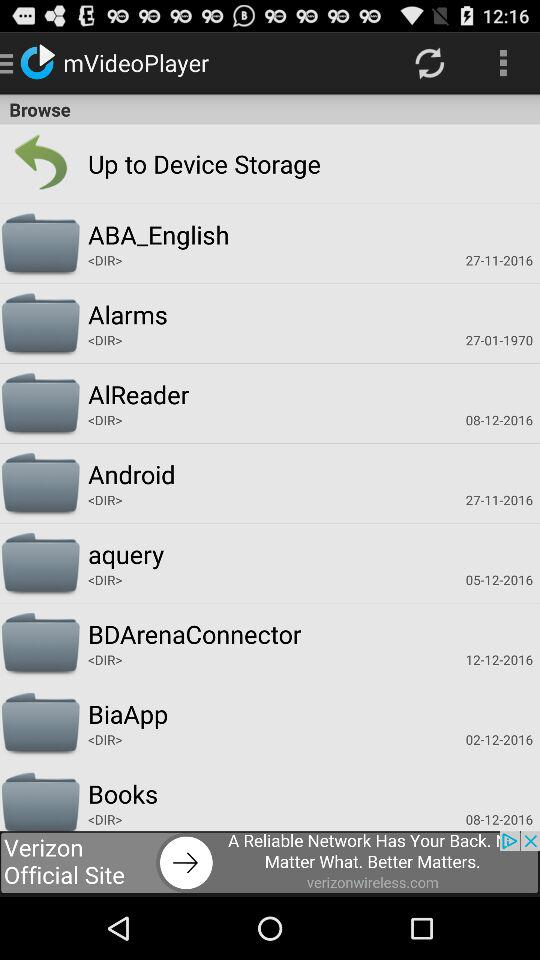What is the name of the application? The name of the application is "mVideoPlayer". 